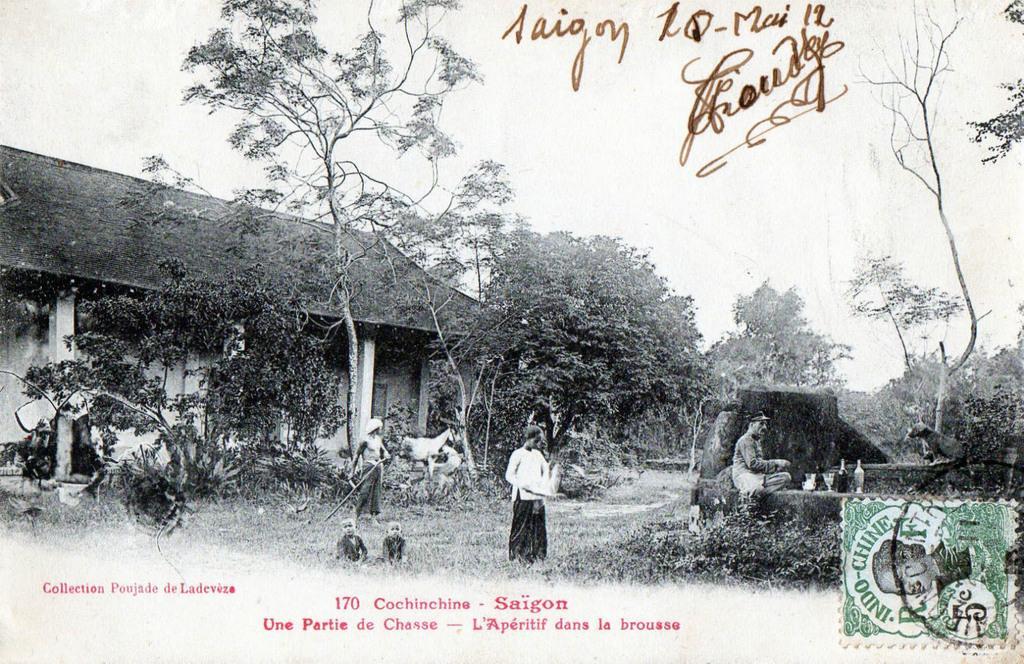Could you give a brief overview of what you see in this image? In this image we can see a photo. In the photo we can see a house, trees, an animal, people and some other objects. At the top of the image there is the sky. On the photo something is written, and there is a stamp on it. 